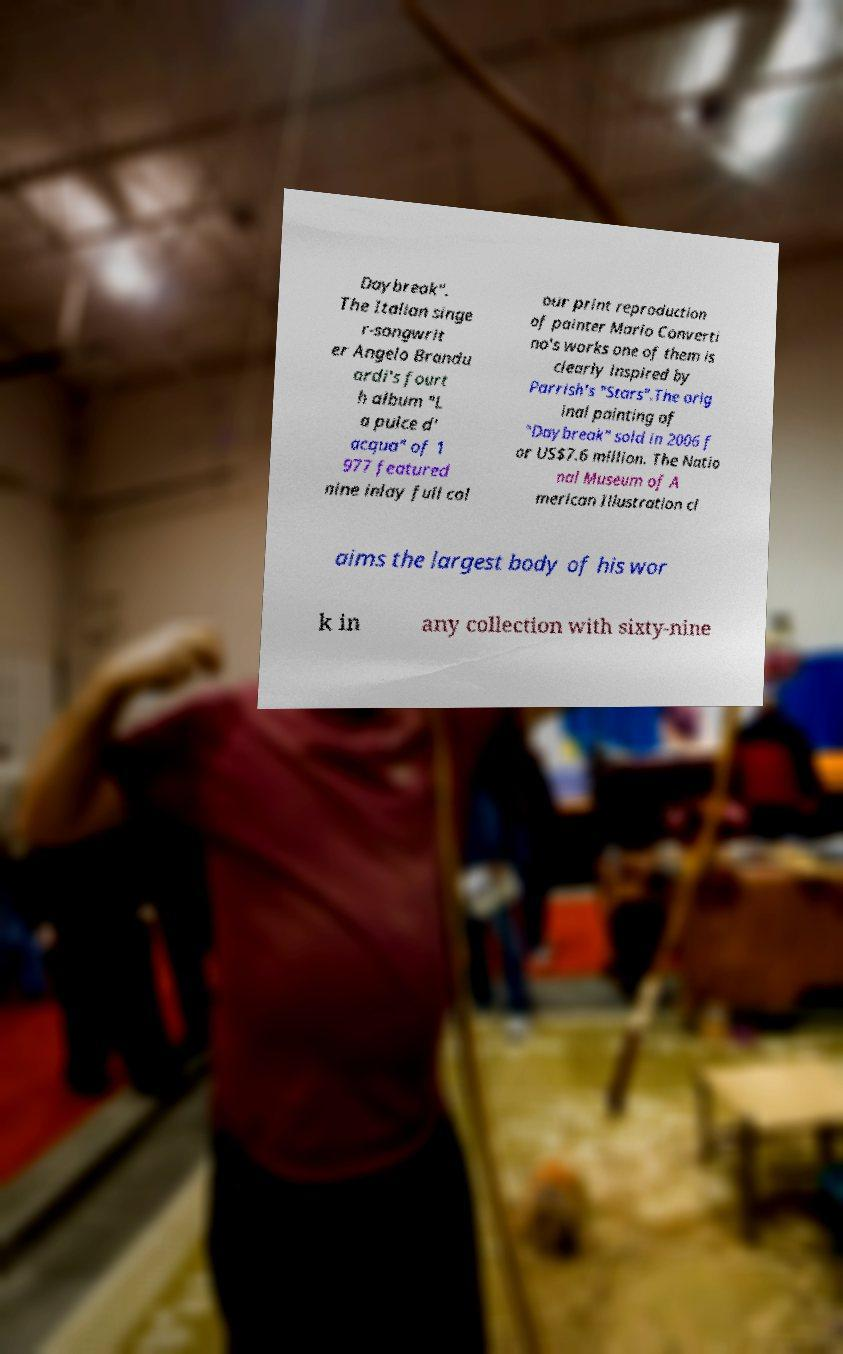Please read and relay the text visible in this image. What does it say? Daybreak". The Italian singe r-songwrit er Angelo Brandu ardi's fourt h album "L a pulce d' acqua" of 1 977 featured nine inlay full col our print reproduction of painter Mario Converti no's works one of them is clearly inspired by Parrish's "Stars".The orig inal painting of "Daybreak" sold in 2006 f or US$7.6 million. The Natio nal Museum of A merican Illustration cl aims the largest body of his wor k in any collection with sixty-nine 